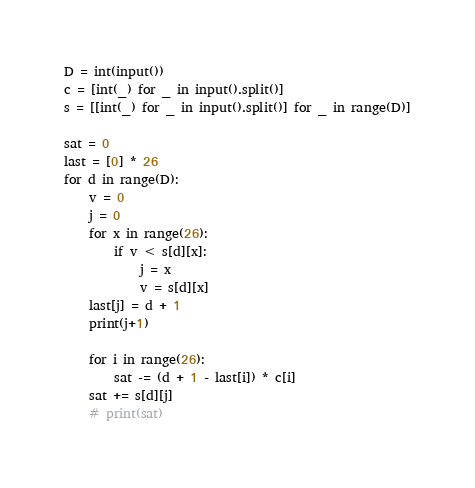Convert code to text. <code><loc_0><loc_0><loc_500><loc_500><_Python_>D = int(input())
c = [int(_) for _ in input().split()]
s = [[int(_) for _ in input().split()] for _ in range(D)]

sat = 0
last = [0] * 26
for d in range(D):
    v = 0
    j = 0
    for x in range(26):
        if v < s[d][x]:
            j = x
            v = s[d][x]
    last[j] = d + 1
    print(j+1)

    for i in range(26):
        sat -= (d + 1 - last[i]) * c[i]
    sat += s[d][j]
    # print(sat)
</code> 